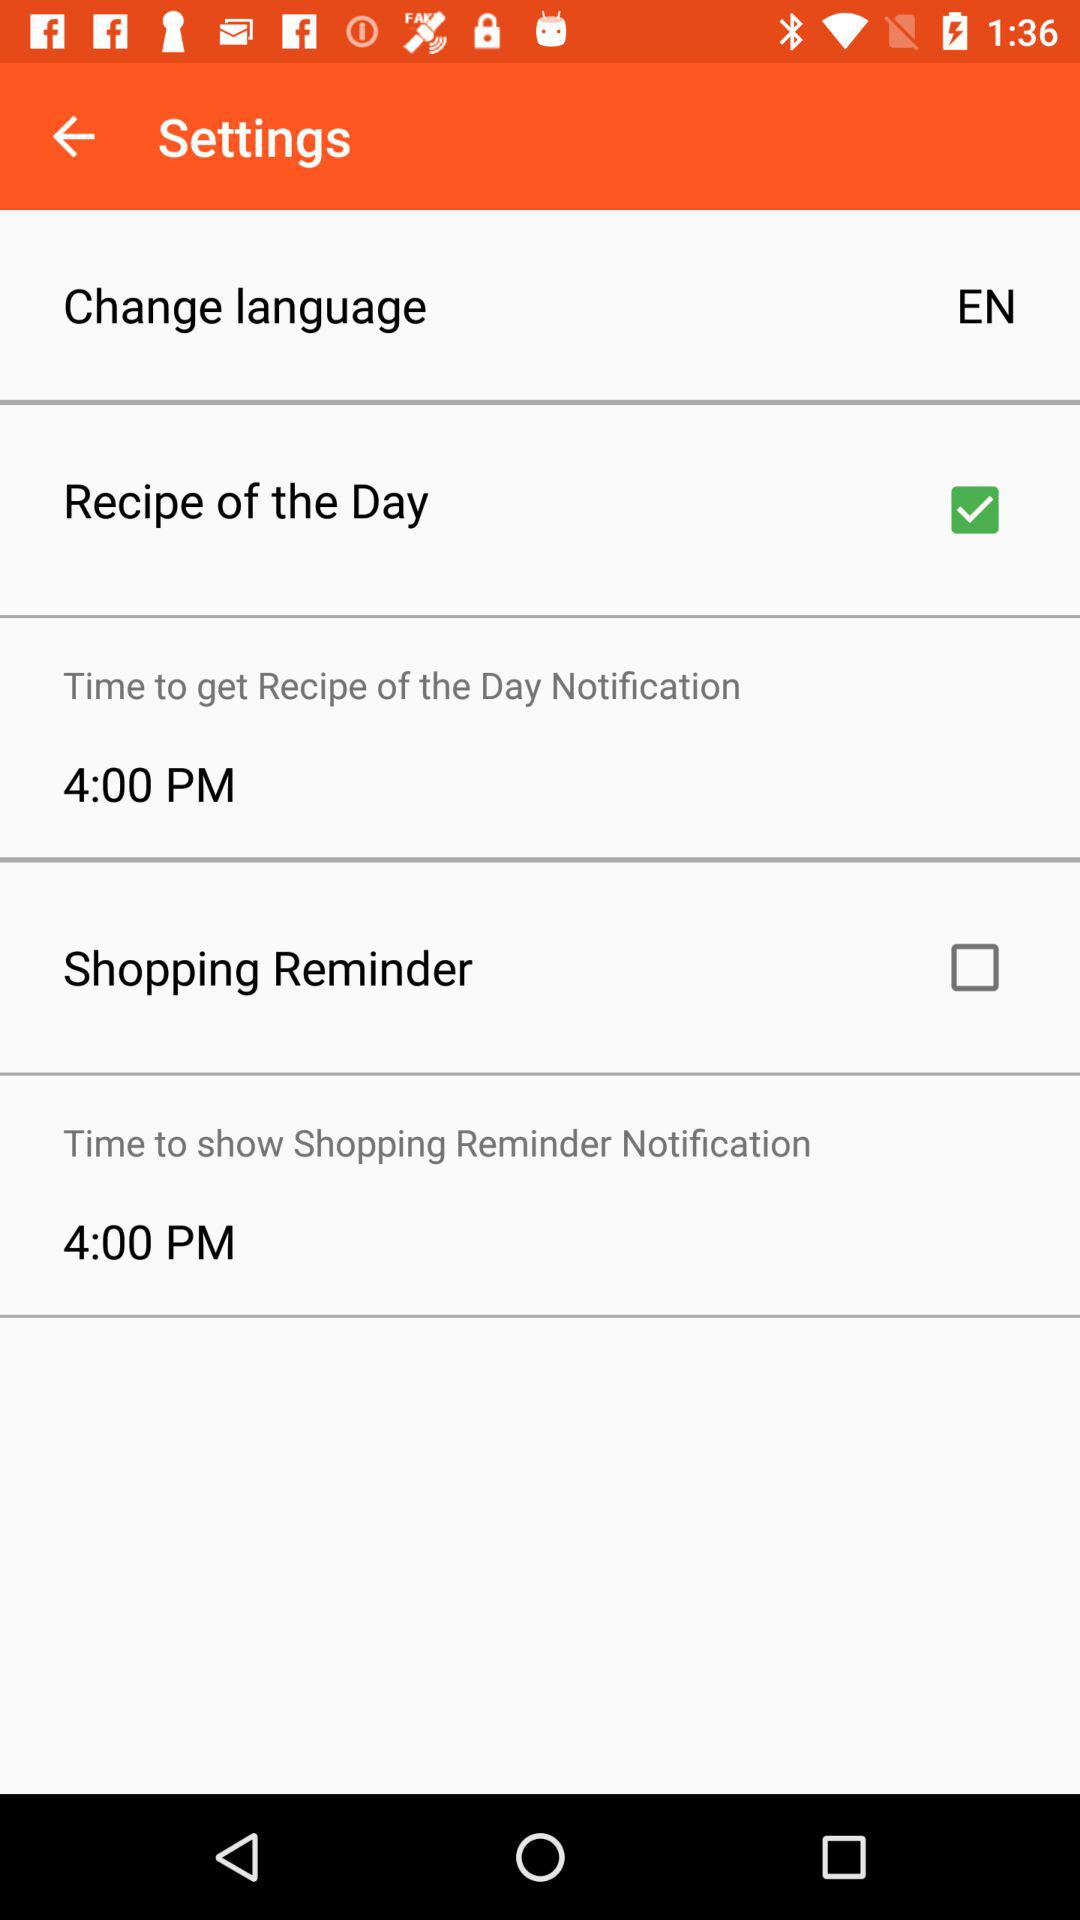Which option is checked? The checked option is "Recipe of the Day". 